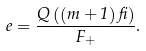Convert formula to latex. <formula><loc_0><loc_0><loc_500><loc_500>e = \frac { Q \left ( \left ( m + 1 \right ) \beta \right ) } { F _ { + } } .</formula> 